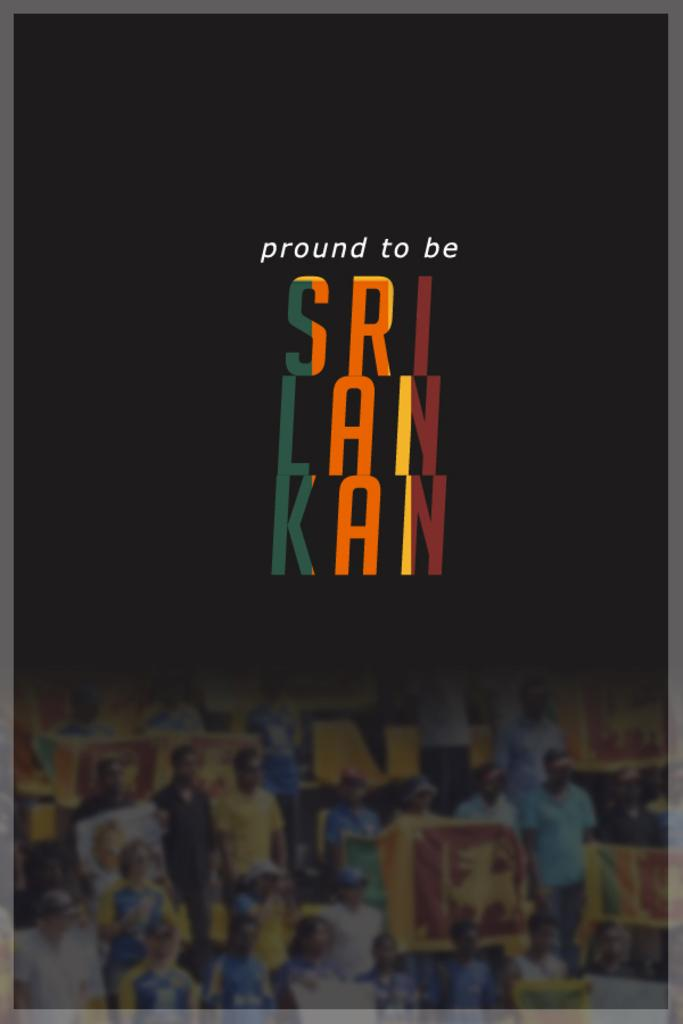What message is conveyed by the poster in the image? The poster in the image has the text "Proud to be SRI LANKAN." What are the people in the image doing? The people in the image are holding banners. What is the chance of finding a bun in the image? There is no mention of a bun in the image, so it cannot be determined if there is a chance of finding one. 